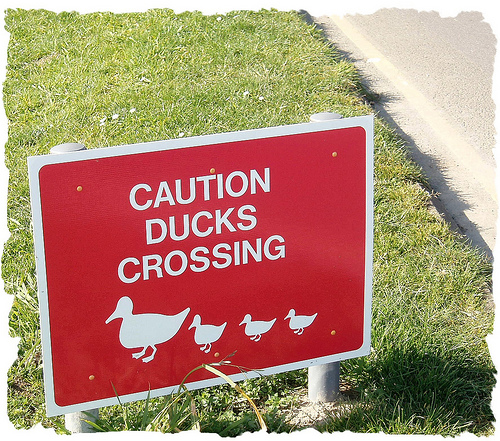<image>
Can you confirm if the sign is behind the grass? No. The sign is not behind the grass. From this viewpoint, the sign appears to be positioned elsewhere in the scene. 